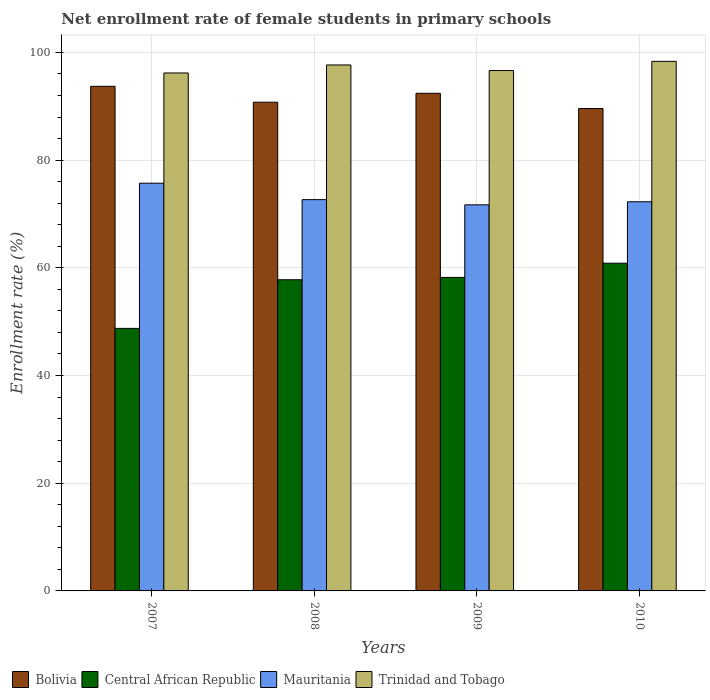Are the number of bars on each tick of the X-axis equal?
Offer a terse response. Yes. How many bars are there on the 4th tick from the left?
Your response must be concise. 4. How many bars are there on the 3rd tick from the right?
Offer a terse response. 4. What is the label of the 4th group of bars from the left?
Offer a very short reply. 2010. In how many cases, is the number of bars for a given year not equal to the number of legend labels?
Offer a terse response. 0. What is the net enrollment rate of female students in primary schools in Central African Republic in 2010?
Ensure brevity in your answer.  60.85. Across all years, what is the maximum net enrollment rate of female students in primary schools in Trinidad and Tobago?
Give a very brief answer. 98.33. Across all years, what is the minimum net enrollment rate of female students in primary schools in Bolivia?
Offer a terse response. 89.57. In which year was the net enrollment rate of female students in primary schools in Mauritania maximum?
Ensure brevity in your answer.  2007. What is the total net enrollment rate of female students in primary schools in Mauritania in the graph?
Provide a short and direct response. 292.31. What is the difference between the net enrollment rate of female students in primary schools in Mauritania in 2007 and that in 2009?
Give a very brief answer. 4.02. What is the difference between the net enrollment rate of female students in primary schools in Trinidad and Tobago in 2008 and the net enrollment rate of female students in primary schools in Mauritania in 2009?
Make the answer very short. 25.97. What is the average net enrollment rate of female students in primary schools in Mauritania per year?
Provide a short and direct response. 73.08. In the year 2009, what is the difference between the net enrollment rate of female students in primary schools in Trinidad and Tobago and net enrollment rate of female students in primary schools in Bolivia?
Make the answer very short. 4.23. In how many years, is the net enrollment rate of female students in primary schools in Bolivia greater than 60 %?
Your answer should be compact. 4. What is the ratio of the net enrollment rate of female students in primary schools in Trinidad and Tobago in 2007 to that in 2010?
Provide a short and direct response. 0.98. Is the net enrollment rate of female students in primary schools in Mauritania in 2007 less than that in 2008?
Keep it short and to the point. No. Is the difference between the net enrollment rate of female students in primary schools in Trinidad and Tobago in 2009 and 2010 greater than the difference between the net enrollment rate of female students in primary schools in Bolivia in 2009 and 2010?
Your answer should be very brief. No. What is the difference between the highest and the second highest net enrollment rate of female students in primary schools in Trinidad and Tobago?
Offer a terse response. 0.67. What is the difference between the highest and the lowest net enrollment rate of female students in primary schools in Central African Republic?
Your answer should be compact. 12.1. Is the sum of the net enrollment rate of female students in primary schools in Central African Republic in 2008 and 2010 greater than the maximum net enrollment rate of female students in primary schools in Bolivia across all years?
Provide a short and direct response. Yes. What does the 2nd bar from the left in 2007 represents?
Your answer should be compact. Central African Republic. What does the 1st bar from the right in 2008 represents?
Your response must be concise. Trinidad and Tobago. How many bars are there?
Your answer should be compact. 16. What is the difference between two consecutive major ticks on the Y-axis?
Your response must be concise. 20. Where does the legend appear in the graph?
Provide a short and direct response. Bottom left. How many legend labels are there?
Provide a succinct answer. 4. How are the legend labels stacked?
Provide a succinct answer. Horizontal. What is the title of the graph?
Make the answer very short. Net enrollment rate of female students in primary schools. Does "Faeroe Islands" appear as one of the legend labels in the graph?
Provide a succinct answer. No. What is the label or title of the X-axis?
Offer a very short reply. Years. What is the label or title of the Y-axis?
Keep it short and to the point. Enrollment rate (%). What is the Enrollment rate (%) of Bolivia in 2007?
Provide a succinct answer. 93.7. What is the Enrollment rate (%) of Central African Republic in 2007?
Give a very brief answer. 48.75. What is the Enrollment rate (%) in Mauritania in 2007?
Give a very brief answer. 75.71. What is the Enrollment rate (%) of Trinidad and Tobago in 2007?
Your answer should be very brief. 96.17. What is the Enrollment rate (%) of Bolivia in 2008?
Your answer should be compact. 90.75. What is the Enrollment rate (%) of Central African Republic in 2008?
Your response must be concise. 57.78. What is the Enrollment rate (%) in Mauritania in 2008?
Provide a short and direct response. 72.66. What is the Enrollment rate (%) of Trinidad and Tobago in 2008?
Provide a short and direct response. 97.66. What is the Enrollment rate (%) in Bolivia in 2009?
Give a very brief answer. 92.4. What is the Enrollment rate (%) in Central African Republic in 2009?
Your answer should be compact. 58.22. What is the Enrollment rate (%) of Mauritania in 2009?
Provide a short and direct response. 71.69. What is the Enrollment rate (%) in Trinidad and Tobago in 2009?
Your answer should be very brief. 96.63. What is the Enrollment rate (%) of Bolivia in 2010?
Keep it short and to the point. 89.57. What is the Enrollment rate (%) in Central African Republic in 2010?
Provide a short and direct response. 60.85. What is the Enrollment rate (%) in Mauritania in 2010?
Your response must be concise. 72.26. What is the Enrollment rate (%) of Trinidad and Tobago in 2010?
Offer a terse response. 98.33. Across all years, what is the maximum Enrollment rate (%) in Bolivia?
Keep it short and to the point. 93.7. Across all years, what is the maximum Enrollment rate (%) in Central African Republic?
Ensure brevity in your answer.  60.85. Across all years, what is the maximum Enrollment rate (%) in Mauritania?
Offer a very short reply. 75.71. Across all years, what is the maximum Enrollment rate (%) in Trinidad and Tobago?
Offer a very short reply. 98.33. Across all years, what is the minimum Enrollment rate (%) of Bolivia?
Offer a terse response. 89.57. Across all years, what is the minimum Enrollment rate (%) of Central African Republic?
Provide a succinct answer. 48.75. Across all years, what is the minimum Enrollment rate (%) of Mauritania?
Provide a succinct answer. 71.69. Across all years, what is the minimum Enrollment rate (%) in Trinidad and Tobago?
Offer a very short reply. 96.17. What is the total Enrollment rate (%) in Bolivia in the graph?
Provide a short and direct response. 366.41. What is the total Enrollment rate (%) of Central African Republic in the graph?
Ensure brevity in your answer.  225.6. What is the total Enrollment rate (%) of Mauritania in the graph?
Your answer should be compact. 292.31. What is the total Enrollment rate (%) in Trinidad and Tobago in the graph?
Give a very brief answer. 388.8. What is the difference between the Enrollment rate (%) in Bolivia in 2007 and that in 2008?
Your response must be concise. 2.95. What is the difference between the Enrollment rate (%) in Central African Republic in 2007 and that in 2008?
Make the answer very short. -9.03. What is the difference between the Enrollment rate (%) of Mauritania in 2007 and that in 2008?
Your answer should be compact. 3.05. What is the difference between the Enrollment rate (%) of Trinidad and Tobago in 2007 and that in 2008?
Keep it short and to the point. -1.49. What is the difference between the Enrollment rate (%) in Bolivia in 2007 and that in 2009?
Your response must be concise. 1.3. What is the difference between the Enrollment rate (%) in Central African Republic in 2007 and that in 2009?
Make the answer very short. -9.47. What is the difference between the Enrollment rate (%) in Mauritania in 2007 and that in 2009?
Provide a succinct answer. 4.02. What is the difference between the Enrollment rate (%) of Trinidad and Tobago in 2007 and that in 2009?
Your answer should be compact. -0.45. What is the difference between the Enrollment rate (%) in Bolivia in 2007 and that in 2010?
Give a very brief answer. 4.13. What is the difference between the Enrollment rate (%) in Central African Republic in 2007 and that in 2010?
Your answer should be very brief. -12.1. What is the difference between the Enrollment rate (%) in Mauritania in 2007 and that in 2010?
Your response must be concise. 3.45. What is the difference between the Enrollment rate (%) in Trinidad and Tobago in 2007 and that in 2010?
Your answer should be compact. -2.16. What is the difference between the Enrollment rate (%) of Bolivia in 2008 and that in 2009?
Give a very brief answer. -1.65. What is the difference between the Enrollment rate (%) of Central African Republic in 2008 and that in 2009?
Ensure brevity in your answer.  -0.44. What is the difference between the Enrollment rate (%) in Mauritania in 2008 and that in 2009?
Your answer should be very brief. 0.96. What is the difference between the Enrollment rate (%) of Trinidad and Tobago in 2008 and that in 2009?
Your answer should be very brief. 1.04. What is the difference between the Enrollment rate (%) of Bolivia in 2008 and that in 2010?
Your answer should be compact. 1.17. What is the difference between the Enrollment rate (%) in Central African Republic in 2008 and that in 2010?
Your answer should be very brief. -3.07. What is the difference between the Enrollment rate (%) of Mauritania in 2008 and that in 2010?
Your response must be concise. 0.4. What is the difference between the Enrollment rate (%) in Trinidad and Tobago in 2008 and that in 2010?
Your answer should be compact. -0.67. What is the difference between the Enrollment rate (%) in Bolivia in 2009 and that in 2010?
Provide a short and direct response. 2.83. What is the difference between the Enrollment rate (%) of Central African Republic in 2009 and that in 2010?
Provide a short and direct response. -2.64. What is the difference between the Enrollment rate (%) of Mauritania in 2009 and that in 2010?
Your response must be concise. -0.57. What is the difference between the Enrollment rate (%) in Trinidad and Tobago in 2009 and that in 2010?
Offer a terse response. -1.71. What is the difference between the Enrollment rate (%) of Bolivia in 2007 and the Enrollment rate (%) of Central African Republic in 2008?
Keep it short and to the point. 35.92. What is the difference between the Enrollment rate (%) of Bolivia in 2007 and the Enrollment rate (%) of Mauritania in 2008?
Your response must be concise. 21.04. What is the difference between the Enrollment rate (%) of Bolivia in 2007 and the Enrollment rate (%) of Trinidad and Tobago in 2008?
Your answer should be compact. -3.96. What is the difference between the Enrollment rate (%) in Central African Republic in 2007 and the Enrollment rate (%) in Mauritania in 2008?
Offer a terse response. -23.91. What is the difference between the Enrollment rate (%) in Central African Republic in 2007 and the Enrollment rate (%) in Trinidad and Tobago in 2008?
Offer a very short reply. -48.91. What is the difference between the Enrollment rate (%) in Mauritania in 2007 and the Enrollment rate (%) in Trinidad and Tobago in 2008?
Offer a terse response. -21.96. What is the difference between the Enrollment rate (%) in Bolivia in 2007 and the Enrollment rate (%) in Central African Republic in 2009?
Provide a short and direct response. 35.48. What is the difference between the Enrollment rate (%) of Bolivia in 2007 and the Enrollment rate (%) of Mauritania in 2009?
Your answer should be very brief. 22.01. What is the difference between the Enrollment rate (%) in Bolivia in 2007 and the Enrollment rate (%) in Trinidad and Tobago in 2009?
Your answer should be very brief. -2.93. What is the difference between the Enrollment rate (%) in Central African Republic in 2007 and the Enrollment rate (%) in Mauritania in 2009?
Make the answer very short. -22.94. What is the difference between the Enrollment rate (%) in Central African Republic in 2007 and the Enrollment rate (%) in Trinidad and Tobago in 2009?
Your answer should be compact. -47.88. What is the difference between the Enrollment rate (%) of Mauritania in 2007 and the Enrollment rate (%) of Trinidad and Tobago in 2009?
Your answer should be compact. -20.92. What is the difference between the Enrollment rate (%) of Bolivia in 2007 and the Enrollment rate (%) of Central African Republic in 2010?
Offer a terse response. 32.84. What is the difference between the Enrollment rate (%) in Bolivia in 2007 and the Enrollment rate (%) in Mauritania in 2010?
Your answer should be compact. 21.44. What is the difference between the Enrollment rate (%) in Bolivia in 2007 and the Enrollment rate (%) in Trinidad and Tobago in 2010?
Your response must be concise. -4.64. What is the difference between the Enrollment rate (%) of Central African Republic in 2007 and the Enrollment rate (%) of Mauritania in 2010?
Provide a succinct answer. -23.51. What is the difference between the Enrollment rate (%) of Central African Republic in 2007 and the Enrollment rate (%) of Trinidad and Tobago in 2010?
Ensure brevity in your answer.  -49.58. What is the difference between the Enrollment rate (%) in Mauritania in 2007 and the Enrollment rate (%) in Trinidad and Tobago in 2010?
Your response must be concise. -22.63. What is the difference between the Enrollment rate (%) of Bolivia in 2008 and the Enrollment rate (%) of Central African Republic in 2009?
Offer a very short reply. 32.53. What is the difference between the Enrollment rate (%) of Bolivia in 2008 and the Enrollment rate (%) of Mauritania in 2009?
Your answer should be very brief. 19.05. What is the difference between the Enrollment rate (%) of Bolivia in 2008 and the Enrollment rate (%) of Trinidad and Tobago in 2009?
Your response must be concise. -5.88. What is the difference between the Enrollment rate (%) of Central African Republic in 2008 and the Enrollment rate (%) of Mauritania in 2009?
Keep it short and to the point. -13.91. What is the difference between the Enrollment rate (%) in Central African Republic in 2008 and the Enrollment rate (%) in Trinidad and Tobago in 2009?
Ensure brevity in your answer.  -38.85. What is the difference between the Enrollment rate (%) of Mauritania in 2008 and the Enrollment rate (%) of Trinidad and Tobago in 2009?
Your answer should be very brief. -23.97. What is the difference between the Enrollment rate (%) of Bolivia in 2008 and the Enrollment rate (%) of Central African Republic in 2010?
Provide a succinct answer. 29.89. What is the difference between the Enrollment rate (%) in Bolivia in 2008 and the Enrollment rate (%) in Mauritania in 2010?
Your answer should be compact. 18.49. What is the difference between the Enrollment rate (%) of Bolivia in 2008 and the Enrollment rate (%) of Trinidad and Tobago in 2010?
Give a very brief answer. -7.59. What is the difference between the Enrollment rate (%) in Central African Republic in 2008 and the Enrollment rate (%) in Mauritania in 2010?
Give a very brief answer. -14.48. What is the difference between the Enrollment rate (%) in Central African Republic in 2008 and the Enrollment rate (%) in Trinidad and Tobago in 2010?
Offer a terse response. -40.55. What is the difference between the Enrollment rate (%) in Mauritania in 2008 and the Enrollment rate (%) in Trinidad and Tobago in 2010?
Keep it short and to the point. -25.68. What is the difference between the Enrollment rate (%) of Bolivia in 2009 and the Enrollment rate (%) of Central African Republic in 2010?
Give a very brief answer. 31.55. What is the difference between the Enrollment rate (%) of Bolivia in 2009 and the Enrollment rate (%) of Mauritania in 2010?
Offer a terse response. 20.14. What is the difference between the Enrollment rate (%) of Bolivia in 2009 and the Enrollment rate (%) of Trinidad and Tobago in 2010?
Give a very brief answer. -5.93. What is the difference between the Enrollment rate (%) of Central African Republic in 2009 and the Enrollment rate (%) of Mauritania in 2010?
Your answer should be very brief. -14.04. What is the difference between the Enrollment rate (%) of Central African Republic in 2009 and the Enrollment rate (%) of Trinidad and Tobago in 2010?
Make the answer very short. -40.12. What is the difference between the Enrollment rate (%) of Mauritania in 2009 and the Enrollment rate (%) of Trinidad and Tobago in 2010?
Make the answer very short. -26.64. What is the average Enrollment rate (%) of Bolivia per year?
Your answer should be very brief. 91.6. What is the average Enrollment rate (%) of Central African Republic per year?
Provide a short and direct response. 56.4. What is the average Enrollment rate (%) in Mauritania per year?
Offer a very short reply. 73.08. What is the average Enrollment rate (%) of Trinidad and Tobago per year?
Keep it short and to the point. 97.2. In the year 2007, what is the difference between the Enrollment rate (%) in Bolivia and Enrollment rate (%) in Central African Republic?
Keep it short and to the point. 44.95. In the year 2007, what is the difference between the Enrollment rate (%) in Bolivia and Enrollment rate (%) in Mauritania?
Keep it short and to the point. 17.99. In the year 2007, what is the difference between the Enrollment rate (%) of Bolivia and Enrollment rate (%) of Trinidad and Tobago?
Provide a succinct answer. -2.48. In the year 2007, what is the difference between the Enrollment rate (%) in Central African Republic and Enrollment rate (%) in Mauritania?
Keep it short and to the point. -26.96. In the year 2007, what is the difference between the Enrollment rate (%) in Central African Republic and Enrollment rate (%) in Trinidad and Tobago?
Your answer should be compact. -47.42. In the year 2007, what is the difference between the Enrollment rate (%) in Mauritania and Enrollment rate (%) in Trinidad and Tobago?
Give a very brief answer. -20.47. In the year 2008, what is the difference between the Enrollment rate (%) in Bolivia and Enrollment rate (%) in Central African Republic?
Make the answer very short. 32.96. In the year 2008, what is the difference between the Enrollment rate (%) in Bolivia and Enrollment rate (%) in Mauritania?
Provide a short and direct response. 18.09. In the year 2008, what is the difference between the Enrollment rate (%) in Bolivia and Enrollment rate (%) in Trinidad and Tobago?
Offer a terse response. -6.92. In the year 2008, what is the difference between the Enrollment rate (%) in Central African Republic and Enrollment rate (%) in Mauritania?
Offer a terse response. -14.88. In the year 2008, what is the difference between the Enrollment rate (%) in Central African Republic and Enrollment rate (%) in Trinidad and Tobago?
Make the answer very short. -39.88. In the year 2008, what is the difference between the Enrollment rate (%) of Mauritania and Enrollment rate (%) of Trinidad and Tobago?
Give a very brief answer. -25.01. In the year 2009, what is the difference between the Enrollment rate (%) of Bolivia and Enrollment rate (%) of Central African Republic?
Your answer should be compact. 34.18. In the year 2009, what is the difference between the Enrollment rate (%) of Bolivia and Enrollment rate (%) of Mauritania?
Offer a very short reply. 20.71. In the year 2009, what is the difference between the Enrollment rate (%) of Bolivia and Enrollment rate (%) of Trinidad and Tobago?
Provide a succinct answer. -4.23. In the year 2009, what is the difference between the Enrollment rate (%) of Central African Republic and Enrollment rate (%) of Mauritania?
Provide a succinct answer. -13.47. In the year 2009, what is the difference between the Enrollment rate (%) of Central African Republic and Enrollment rate (%) of Trinidad and Tobago?
Your response must be concise. -38.41. In the year 2009, what is the difference between the Enrollment rate (%) of Mauritania and Enrollment rate (%) of Trinidad and Tobago?
Your answer should be very brief. -24.94. In the year 2010, what is the difference between the Enrollment rate (%) in Bolivia and Enrollment rate (%) in Central African Republic?
Provide a short and direct response. 28.72. In the year 2010, what is the difference between the Enrollment rate (%) of Bolivia and Enrollment rate (%) of Mauritania?
Provide a succinct answer. 17.31. In the year 2010, what is the difference between the Enrollment rate (%) of Bolivia and Enrollment rate (%) of Trinidad and Tobago?
Keep it short and to the point. -8.76. In the year 2010, what is the difference between the Enrollment rate (%) in Central African Republic and Enrollment rate (%) in Mauritania?
Your answer should be compact. -11.41. In the year 2010, what is the difference between the Enrollment rate (%) in Central African Republic and Enrollment rate (%) in Trinidad and Tobago?
Provide a succinct answer. -37.48. In the year 2010, what is the difference between the Enrollment rate (%) of Mauritania and Enrollment rate (%) of Trinidad and Tobago?
Make the answer very short. -26.07. What is the ratio of the Enrollment rate (%) in Bolivia in 2007 to that in 2008?
Make the answer very short. 1.03. What is the ratio of the Enrollment rate (%) of Central African Republic in 2007 to that in 2008?
Offer a terse response. 0.84. What is the ratio of the Enrollment rate (%) of Mauritania in 2007 to that in 2008?
Give a very brief answer. 1.04. What is the ratio of the Enrollment rate (%) in Bolivia in 2007 to that in 2009?
Make the answer very short. 1.01. What is the ratio of the Enrollment rate (%) of Central African Republic in 2007 to that in 2009?
Offer a very short reply. 0.84. What is the ratio of the Enrollment rate (%) in Mauritania in 2007 to that in 2009?
Make the answer very short. 1.06. What is the ratio of the Enrollment rate (%) of Trinidad and Tobago in 2007 to that in 2009?
Keep it short and to the point. 1. What is the ratio of the Enrollment rate (%) in Bolivia in 2007 to that in 2010?
Ensure brevity in your answer.  1.05. What is the ratio of the Enrollment rate (%) of Central African Republic in 2007 to that in 2010?
Offer a terse response. 0.8. What is the ratio of the Enrollment rate (%) in Mauritania in 2007 to that in 2010?
Provide a succinct answer. 1.05. What is the ratio of the Enrollment rate (%) in Trinidad and Tobago in 2007 to that in 2010?
Give a very brief answer. 0.98. What is the ratio of the Enrollment rate (%) of Bolivia in 2008 to that in 2009?
Your answer should be very brief. 0.98. What is the ratio of the Enrollment rate (%) of Central African Republic in 2008 to that in 2009?
Provide a short and direct response. 0.99. What is the ratio of the Enrollment rate (%) of Mauritania in 2008 to that in 2009?
Make the answer very short. 1.01. What is the ratio of the Enrollment rate (%) in Trinidad and Tobago in 2008 to that in 2009?
Your answer should be very brief. 1.01. What is the ratio of the Enrollment rate (%) in Bolivia in 2008 to that in 2010?
Offer a terse response. 1.01. What is the ratio of the Enrollment rate (%) in Central African Republic in 2008 to that in 2010?
Your answer should be very brief. 0.95. What is the ratio of the Enrollment rate (%) of Trinidad and Tobago in 2008 to that in 2010?
Offer a very short reply. 0.99. What is the ratio of the Enrollment rate (%) in Bolivia in 2009 to that in 2010?
Offer a very short reply. 1.03. What is the ratio of the Enrollment rate (%) of Central African Republic in 2009 to that in 2010?
Ensure brevity in your answer.  0.96. What is the ratio of the Enrollment rate (%) of Mauritania in 2009 to that in 2010?
Keep it short and to the point. 0.99. What is the ratio of the Enrollment rate (%) in Trinidad and Tobago in 2009 to that in 2010?
Ensure brevity in your answer.  0.98. What is the difference between the highest and the second highest Enrollment rate (%) of Bolivia?
Give a very brief answer. 1.3. What is the difference between the highest and the second highest Enrollment rate (%) of Central African Republic?
Your answer should be very brief. 2.64. What is the difference between the highest and the second highest Enrollment rate (%) in Mauritania?
Give a very brief answer. 3.05. What is the difference between the highest and the second highest Enrollment rate (%) of Trinidad and Tobago?
Your response must be concise. 0.67. What is the difference between the highest and the lowest Enrollment rate (%) of Bolivia?
Give a very brief answer. 4.13. What is the difference between the highest and the lowest Enrollment rate (%) in Central African Republic?
Your response must be concise. 12.1. What is the difference between the highest and the lowest Enrollment rate (%) of Mauritania?
Your answer should be very brief. 4.02. What is the difference between the highest and the lowest Enrollment rate (%) of Trinidad and Tobago?
Make the answer very short. 2.16. 